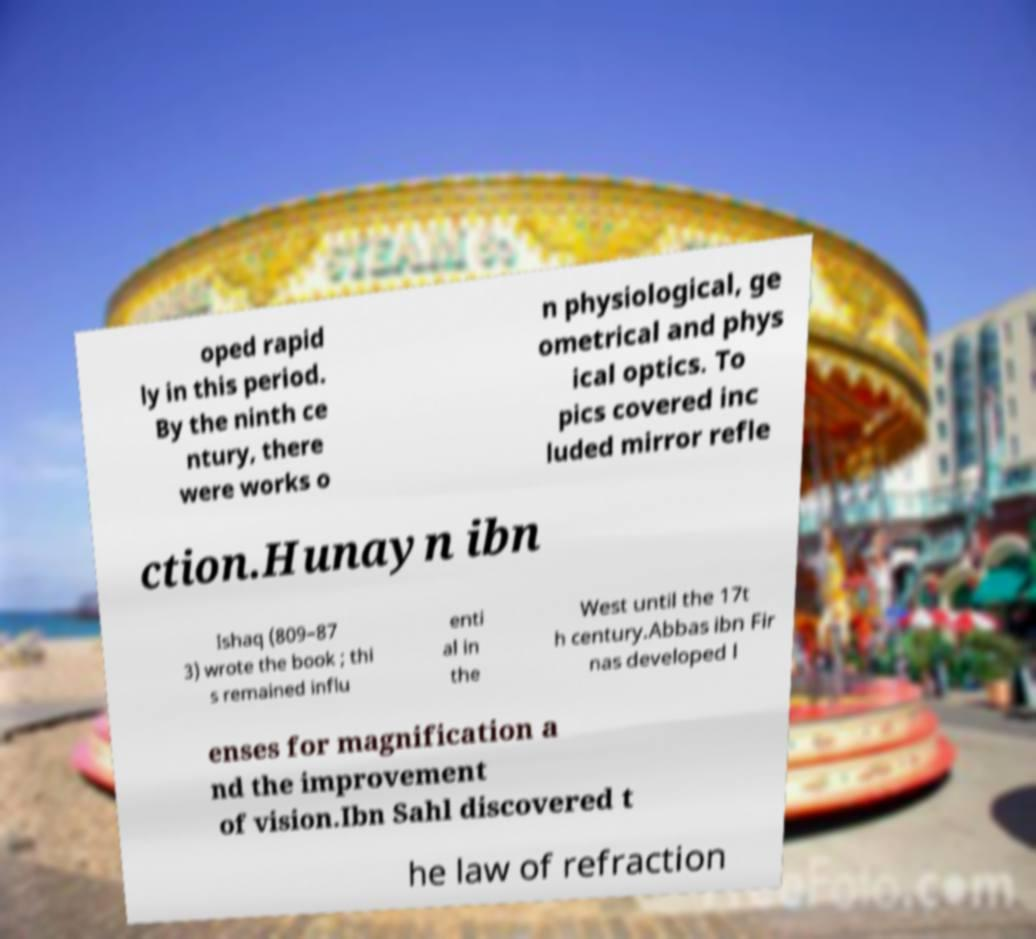Please identify and transcribe the text found in this image. oped rapid ly in this period. By the ninth ce ntury, there were works o n physiological, ge ometrical and phys ical optics. To pics covered inc luded mirror refle ction.Hunayn ibn Ishaq (809–87 3) wrote the book ; thi s remained influ enti al in the West until the 17t h century.Abbas ibn Fir nas developed l enses for magnification a nd the improvement of vision.Ibn Sahl discovered t he law of refraction 